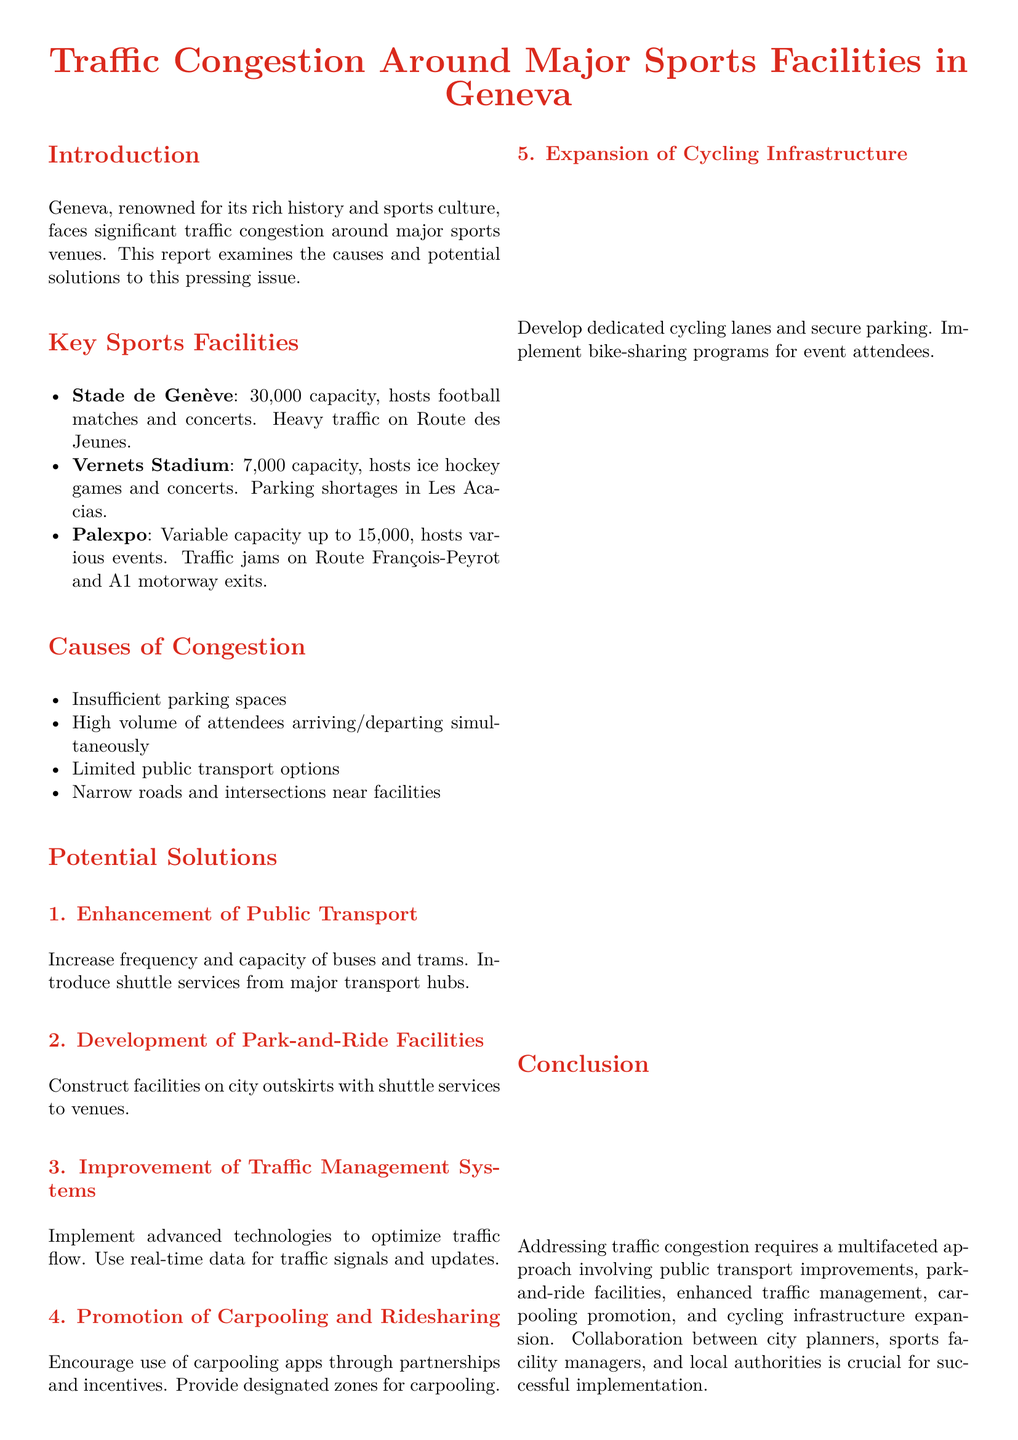What is the capacity of Stade de Genève? The capacity of Stade de Genève is mentioned in the document as 30,000.
Answer: 30,000 What are the traffic issues highlighted for Vernets Stadium? The document specifies parking shortages in Les Acacias as a traffic issue for Vernets Stadium.
Answer: Parking shortages How many potential solutions are proposed in the report? The document lists five potential solutions to address traffic congestion.
Answer: Five What specific type of transportation improvement is suggested to address congestion? The report suggests increasing the frequency and capacity of buses and trams as a transportation improvement.
Answer: Buses and trams What modern integration does the document emphasize for managing traffic congestion? The report emphasizes the integration of modern technology for optimizing traffic flow and management.
Answer: Modern technology Which city does the report focus on regarding traffic congestion? The city being analyzed for traffic congestion is Geneva, as stated in the introduction.
Answer: Geneva What is the main call to action in the report? The call to action focuses on collaboration between city planners, sports facility managers, and local authorities for traffic management initiatives.
Answer: Collaboration What expansion is proposed to support event attendees' travel? The report proposes the expansion of cycling infrastructure to support attendees traveling to events.
Answer: Cycling infrastructure What does the traffic congestion primarily affect near sports facilities? The document indicates that the narrow roads and intersections near facilities primarily affect traffic congestion.
Answer: Narrow roads and intersections 